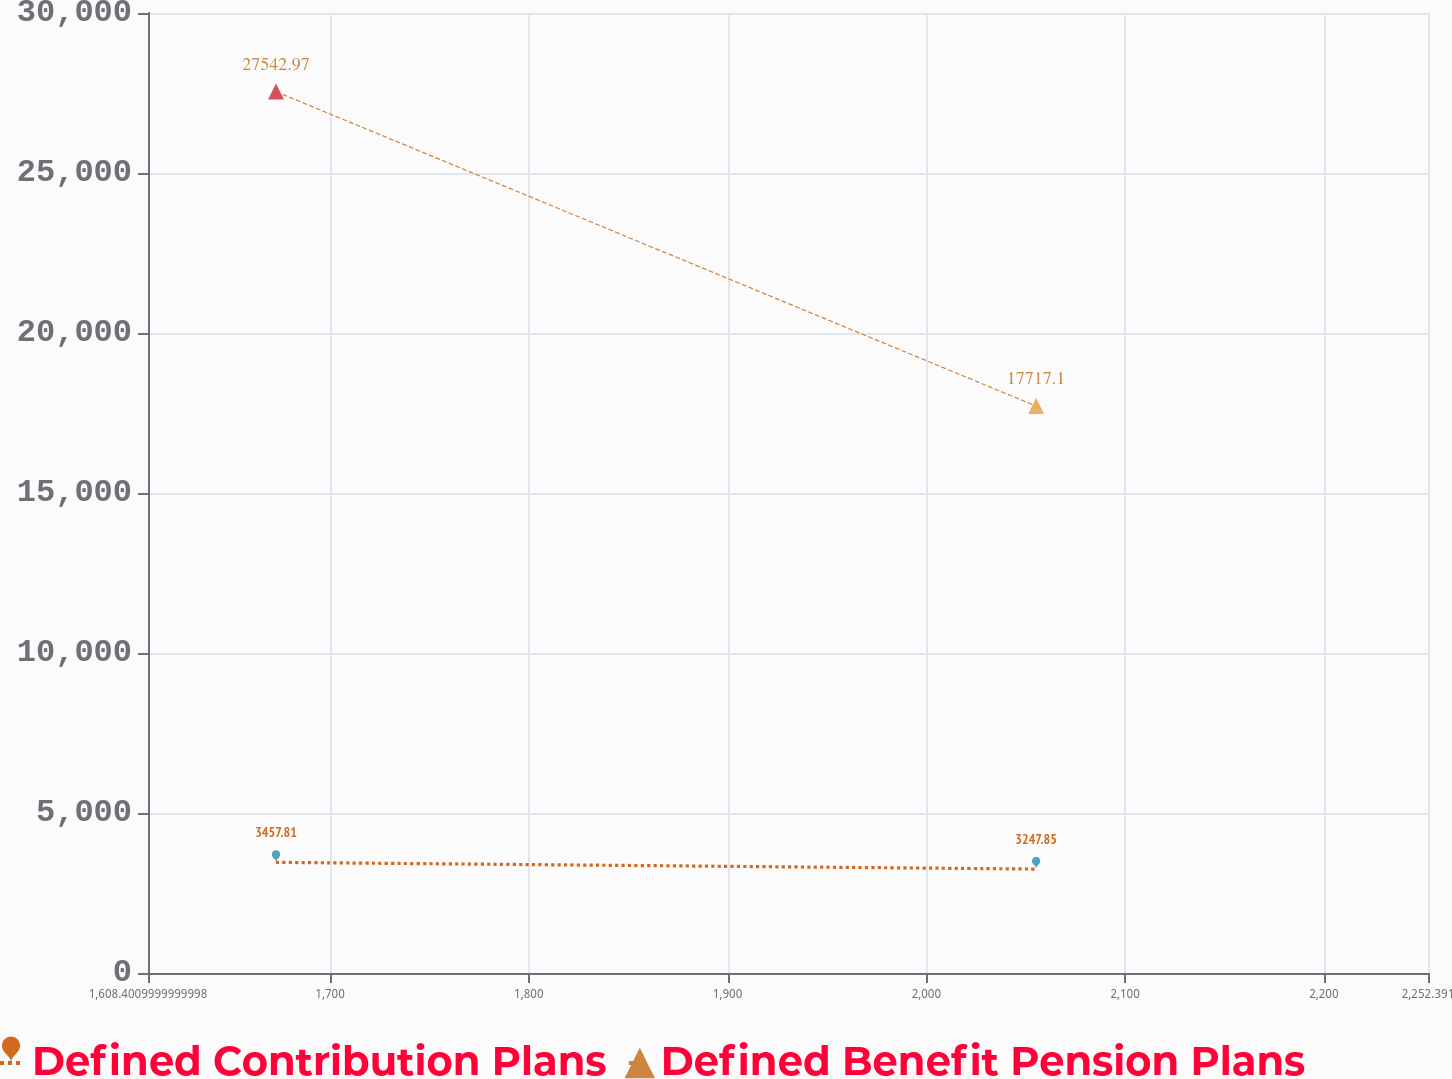Convert chart. <chart><loc_0><loc_0><loc_500><loc_500><line_chart><ecel><fcel>Defined Contribution Plans<fcel>Defined Benefit Pension Plans<nl><fcel>1672.8<fcel>3457.81<fcel>27543<nl><fcel>2055.22<fcel>3247.85<fcel>17717.1<nl><fcel>2316.79<fcel>4187.28<fcel>16579.8<nl></chart> 